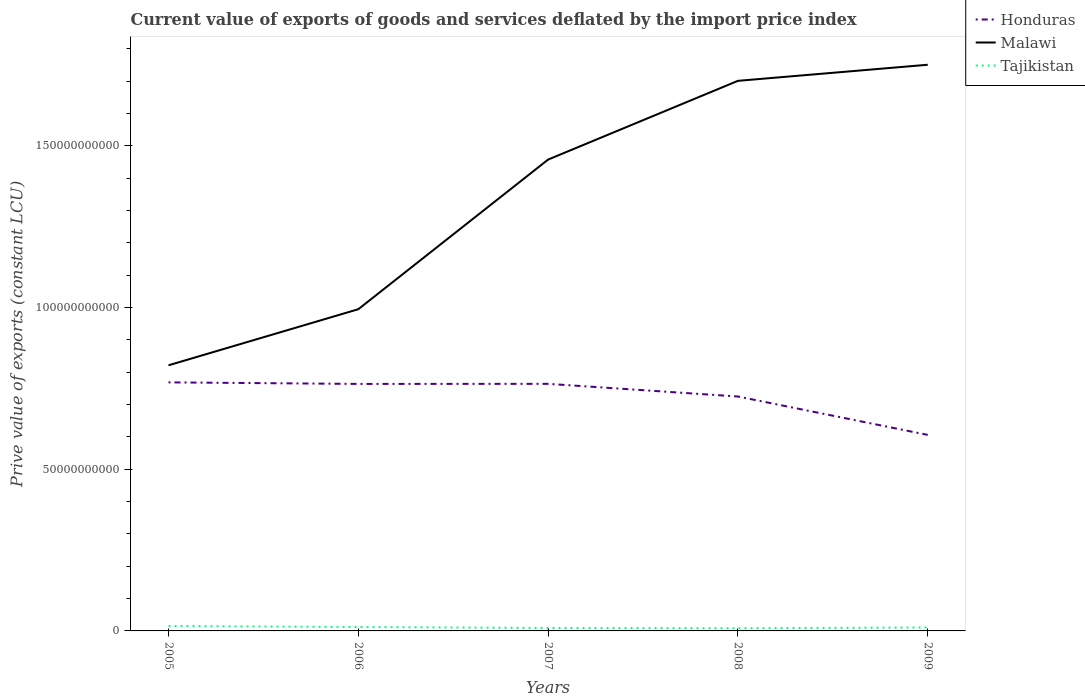Is the number of lines equal to the number of legend labels?
Make the answer very short. Yes. Across all years, what is the maximum prive value of exports in Honduras?
Your response must be concise. 6.06e+1. In which year was the prive value of exports in Tajikistan maximum?
Your response must be concise. 2008. What is the total prive value of exports in Tajikistan in the graph?
Your answer should be compact. 7.74e+07. What is the difference between the highest and the second highest prive value of exports in Honduras?
Provide a succinct answer. 1.62e+1. How many lines are there?
Offer a very short reply. 3. Where does the legend appear in the graph?
Make the answer very short. Top right. How many legend labels are there?
Your answer should be compact. 3. What is the title of the graph?
Your response must be concise. Current value of exports of goods and services deflated by the import price index. Does "Puerto Rico" appear as one of the legend labels in the graph?
Offer a very short reply. No. What is the label or title of the X-axis?
Ensure brevity in your answer.  Years. What is the label or title of the Y-axis?
Ensure brevity in your answer.  Prive value of exports (constant LCU). What is the Prive value of exports (constant LCU) in Honduras in 2005?
Provide a succinct answer. 7.68e+1. What is the Prive value of exports (constant LCU) of Malawi in 2005?
Offer a terse response. 8.21e+1. What is the Prive value of exports (constant LCU) of Tajikistan in 2005?
Your answer should be compact. 1.53e+09. What is the Prive value of exports (constant LCU) of Honduras in 2006?
Your answer should be compact. 7.64e+1. What is the Prive value of exports (constant LCU) of Malawi in 2006?
Your answer should be very brief. 9.95e+1. What is the Prive value of exports (constant LCU) of Tajikistan in 2006?
Make the answer very short. 1.21e+09. What is the Prive value of exports (constant LCU) of Honduras in 2007?
Provide a short and direct response. 7.64e+1. What is the Prive value of exports (constant LCU) of Malawi in 2007?
Offer a terse response. 1.46e+11. What is the Prive value of exports (constant LCU) of Tajikistan in 2007?
Your answer should be very brief. 9.08e+08. What is the Prive value of exports (constant LCU) of Honduras in 2008?
Offer a terse response. 7.25e+1. What is the Prive value of exports (constant LCU) of Malawi in 2008?
Give a very brief answer. 1.70e+11. What is the Prive value of exports (constant LCU) in Tajikistan in 2008?
Your response must be concise. 8.31e+08. What is the Prive value of exports (constant LCU) in Honduras in 2009?
Give a very brief answer. 6.06e+1. What is the Prive value of exports (constant LCU) of Malawi in 2009?
Provide a short and direct response. 1.75e+11. What is the Prive value of exports (constant LCU) in Tajikistan in 2009?
Your answer should be compact. 1.07e+09. Across all years, what is the maximum Prive value of exports (constant LCU) of Honduras?
Offer a very short reply. 7.68e+1. Across all years, what is the maximum Prive value of exports (constant LCU) in Malawi?
Offer a very short reply. 1.75e+11. Across all years, what is the maximum Prive value of exports (constant LCU) in Tajikistan?
Provide a succinct answer. 1.53e+09. Across all years, what is the minimum Prive value of exports (constant LCU) in Honduras?
Ensure brevity in your answer.  6.06e+1. Across all years, what is the minimum Prive value of exports (constant LCU) in Malawi?
Offer a very short reply. 8.21e+1. Across all years, what is the minimum Prive value of exports (constant LCU) of Tajikistan?
Provide a short and direct response. 8.31e+08. What is the total Prive value of exports (constant LCU) in Honduras in the graph?
Give a very brief answer. 3.63e+11. What is the total Prive value of exports (constant LCU) in Malawi in the graph?
Provide a succinct answer. 6.72e+11. What is the total Prive value of exports (constant LCU) of Tajikistan in the graph?
Your answer should be very brief. 5.54e+09. What is the difference between the Prive value of exports (constant LCU) in Honduras in 2005 and that in 2006?
Ensure brevity in your answer.  4.82e+08. What is the difference between the Prive value of exports (constant LCU) of Malawi in 2005 and that in 2006?
Your answer should be very brief. -1.73e+1. What is the difference between the Prive value of exports (constant LCU) in Tajikistan in 2005 and that in 2006?
Your response must be concise. 3.24e+08. What is the difference between the Prive value of exports (constant LCU) of Honduras in 2005 and that in 2007?
Offer a terse response. 4.58e+08. What is the difference between the Prive value of exports (constant LCU) in Malawi in 2005 and that in 2007?
Ensure brevity in your answer.  -6.36e+1. What is the difference between the Prive value of exports (constant LCU) of Tajikistan in 2005 and that in 2007?
Offer a very short reply. 6.22e+08. What is the difference between the Prive value of exports (constant LCU) in Honduras in 2005 and that in 2008?
Offer a very short reply. 4.37e+09. What is the difference between the Prive value of exports (constant LCU) in Malawi in 2005 and that in 2008?
Your answer should be very brief. -8.80e+1. What is the difference between the Prive value of exports (constant LCU) of Tajikistan in 2005 and that in 2008?
Keep it short and to the point. 6.99e+08. What is the difference between the Prive value of exports (constant LCU) in Honduras in 2005 and that in 2009?
Your answer should be very brief. 1.62e+1. What is the difference between the Prive value of exports (constant LCU) in Malawi in 2005 and that in 2009?
Keep it short and to the point. -9.29e+1. What is the difference between the Prive value of exports (constant LCU) in Tajikistan in 2005 and that in 2009?
Make the answer very short. 4.65e+08. What is the difference between the Prive value of exports (constant LCU) in Honduras in 2006 and that in 2007?
Your answer should be compact. -2.36e+07. What is the difference between the Prive value of exports (constant LCU) in Malawi in 2006 and that in 2007?
Make the answer very short. -4.63e+1. What is the difference between the Prive value of exports (constant LCU) in Tajikistan in 2006 and that in 2007?
Offer a very short reply. 2.98e+08. What is the difference between the Prive value of exports (constant LCU) of Honduras in 2006 and that in 2008?
Offer a terse response. 3.89e+09. What is the difference between the Prive value of exports (constant LCU) in Malawi in 2006 and that in 2008?
Your answer should be very brief. -7.06e+1. What is the difference between the Prive value of exports (constant LCU) of Tajikistan in 2006 and that in 2008?
Offer a very short reply. 3.76e+08. What is the difference between the Prive value of exports (constant LCU) in Honduras in 2006 and that in 2009?
Ensure brevity in your answer.  1.58e+1. What is the difference between the Prive value of exports (constant LCU) of Malawi in 2006 and that in 2009?
Give a very brief answer. -7.56e+1. What is the difference between the Prive value of exports (constant LCU) of Tajikistan in 2006 and that in 2009?
Give a very brief answer. 1.41e+08. What is the difference between the Prive value of exports (constant LCU) of Honduras in 2007 and that in 2008?
Your response must be concise. 3.92e+09. What is the difference between the Prive value of exports (constant LCU) in Malawi in 2007 and that in 2008?
Your answer should be compact. -2.43e+1. What is the difference between the Prive value of exports (constant LCU) in Tajikistan in 2007 and that in 2008?
Make the answer very short. 7.74e+07. What is the difference between the Prive value of exports (constant LCU) of Honduras in 2007 and that in 2009?
Keep it short and to the point. 1.58e+1. What is the difference between the Prive value of exports (constant LCU) in Malawi in 2007 and that in 2009?
Keep it short and to the point. -2.93e+1. What is the difference between the Prive value of exports (constant LCU) in Tajikistan in 2007 and that in 2009?
Provide a succinct answer. -1.57e+08. What is the difference between the Prive value of exports (constant LCU) in Honduras in 2008 and that in 2009?
Make the answer very short. 1.19e+1. What is the difference between the Prive value of exports (constant LCU) in Malawi in 2008 and that in 2009?
Give a very brief answer. -4.97e+09. What is the difference between the Prive value of exports (constant LCU) in Tajikistan in 2008 and that in 2009?
Offer a very short reply. -2.35e+08. What is the difference between the Prive value of exports (constant LCU) in Honduras in 2005 and the Prive value of exports (constant LCU) in Malawi in 2006?
Your answer should be very brief. -2.26e+1. What is the difference between the Prive value of exports (constant LCU) of Honduras in 2005 and the Prive value of exports (constant LCU) of Tajikistan in 2006?
Offer a terse response. 7.56e+1. What is the difference between the Prive value of exports (constant LCU) in Malawi in 2005 and the Prive value of exports (constant LCU) in Tajikistan in 2006?
Ensure brevity in your answer.  8.09e+1. What is the difference between the Prive value of exports (constant LCU) of Honduras in 2005 and the Prive value of exports (constant LCU) of Malawi in 2007?
Offer a terse response. -6.89e+1. What is the difference between the Prive value of exports (constant LCU) in Honduras in 2005 and the Prive value of exports (constant LCU) in Tajikistan in 2007?
Make the answer very short. 7.59e+1. What is the difference between the Prive value of exports (constant LCU) of Malawi in 2005 and the Prive value of exports (constant LCU) of Tajikistan in 2007?
Offer a terse response. 8.12e+1. What is the difference between the Prive value of exports (constant LCU) in Honduras in 2005 and the Prive value of exports (constant LCU) in Malawi in 2008?
Your answer should be compact. -9.32e+1. What is the difference between the Prive value of exports (constant LCU) in Honduras in 2005 and the Prive value of exports (constant LCU) in Tajikistan in 2008?
Provide a succinct answer. 7.60e+1. What is the difference between the Prive value of exports (constant LCU) in Malawi in 2005 and the Prive value of exports (constant LCU) in Tajikistan in 2008?
Provide a succinct answer. 8.13e+1. What is the difference between the Prive value of exports (constant LCU) in Honduras in 2005 and the Prive value of exports (constant LCU) in Malawi in 2009?
Keep it short and to the point. -9.82e+1. What is the difference between the Prive value of exports (constant LCU) in Honduras in 2005 and the Prive value of exports (constant LCU) in Tajikistan in 2009?
Offer a very short reply. 7.58e+1. What is the difference between the Prive value of exports (constant LCU) in Malawi in 2005 and the Prive value of exports (constant LCU) in Tajikistan in 2009?
Your response must be concise. 8.11e+1. What is the difference between the Prive value of exports (constant LCU) of Honduras in 2006 and the Prive value of exports (constant LCU) of Malawi in 2007?
Give a very brief answer. -6.94e+1. What is the difference between the Prive value of exports (constant LCU) in Honduras in 2006 and the Prive value of exports (constant LCU) in Tajikistan in 2007?
Ensure brevity in your answer.  7.55e+1. What is the difference between the Prive value of exports (constant LCU) of Malawi in 2006 and the Prive value of exports (constant LCU) of Tajikistan in 2007?
Provide a succinct answer. 9.86e+1. What is the difference between the Prive value of exports (constant LCU) of Honduras in 2006 and the Prive value of exports (constant LCU) of Malawi in 2008?
Provide a succinct answer. -9.37e+1. What is the difference between the Prive value of exports (constant LCU) in Honduras in 2006 and the Prive value of exports (constant LCU) in Tajikistan in 2008?
Your answer should be very brief. 7.55e+1. What is the difference between the Prive value of exports (constant LCU) in Malawi in 2006 and the Prive value of exports (constant LCU) in Tajikistan in 2008?
Make the answer very short. 9.86e+1. What is the difference between the Prive value of exports (constant LCU) in Honduras in 2006 and the Prive value of exports (constant LCU) in Malawi in 2009?
Make the answer very short. -9.87e+1. What is the difference between the Prive value of exports (constant LCU) in Honduras in 2006 and the Prive value of exports (constant LCU) in Tajikistan in 2009?
Offer a very short reply. 7.53e+1. What is the difference between the Prive value of exports (constant LCU) in Malawi in 2006 and the Prive value of exports (constant LCU) in Tajikistan in 2009?
Offer a terse response. 9.84e+1. What is the difference between the Prive value of exports (constant LCU) of Honduras in 2007 and the Prive value of exports (constant LCU) of Malawi in 2008?
Ensure brevity in your answer.  -9.37e+1. What is the difference between the Prive value of exports (constant LCU) in Honduras in 2007 and the Prive value of exports (constant LCU) in Tajikistan in 2008?
Provide a succinct answer. 7.56e+1. What is the difference between the Prive value of exports (constant LCU) in Malawi in 2007 and the Prive value of exports (constant LCU) in Tajikistan in 2008?
Give a very brief answer. 1.45e+11. What is the difference between the Prive value of exports (constant LCU) of Honduras in 2007 and the Prive value of exports (constant LCU) of Malawi in 2009?
Your response must be concise. -9.87e+1. What is the difference between the Prive value of exports (constant LCU) of Honduras in 2007 and the Prive value of exports (constant LCU) of Tajikistan in 2009?
Your response must be concise. 7.53e+1. What is the difference between the Prive value of exports (constant LCU) of Malawi in 2007 and the Prive value of exports (constant LCU) of Tajikistan in 2009?
Keep it short and to the point. 1.45e+11. What is the difference between the Prive value of exports (constant LCU) of Honduras in 2008 and the Prive value of exports (constant LCU) of Malawi in 2009?
Give a very brief answer. -1.03e+11. What is the difference between the Prive value of exports (constant LCU) in Honduras in 2008 and the Prive value of exports (constant LCU) in Tajikistan in 2009?
Your response must be concise. 7.14e+1. What is the difference between the Prive value of exports (constant LCU) in Malawi in 2008 and the Prive value of exports (constant LCU) in Tajikistan in 2009?
Make the answer very short. 1.69e+11. What is the average Prive value of exports (constant LCU) in Honduras per year?
Give a very brief answer. 7.25e+1. What is the average Prive value of exports (constant LCU) in Malawi per year?
Provide a short and direct response. 1.34e+11. What is the average Prive value of exports (constant LCU) of Tajikistan per year?
Offer a terse response. 1.11e+09. In the year 2005, what is the difference between the Prive value of exports (constant LCU) of Honduras and Prive value of exports (constant LCU) of Malawi?
Provide a short and direct response. -5.27e+09. In the year 2005, what is the difference between the Prive value of exports (constant LCU) of Honduras and Prive value of exports (constant LCU) of Tajikistan?
Provide a succinct answer. 7.53e+1. In the year 2005, what is the difference between the Prive value of exports (constant LCU) of Malawi and Prive value of exports (constant LCU) of Tajikistan?
Your answer should be compact. 8.06e+1. In the year 2006, what is the difference between the Prive value of exports (constant LCU) of Honduras and Prive value of exports (constant LCU) of Malawi?
Offer a terse response. -2.31e+1. In the year 2006, what is the difference between the Prive value of exports (constant LCU) of Honduras and Prive value of exports (constant LCU) of Tajikistan?
Provide a short and direct response. 7.52e+1. In the year 2006, what is the difference between the Prive value of exports (constant LCU) of Malawi and Prive value of exports (constant LCU) of Tajikistan?
Offer a very short reply. 9.83e+1. In the year 2007, what is the difference between the Prive value of exports (constant LCU) of Honduras and Prive value of exports (constant LCU) of Malawi?
Your answer should be compact. -6.93e+1. In the year 2007, what is the difference between the Prive value of exports (constant LCU) in Honduras and Prive value of exports (constant LCU) in Tajikistan?
Provide a short and direct response. 7.55e+1. In the year 2007, what is the difference between the Prive value of exports (constant LCU) in Malawi and Prive value of exports (constant LCU) in Tajikistan?
Ensure brevity in your answer.  1.45e+11. In the year 2008, what is the difference between the Prive value of exports (constant LCU) of Honduras and Prive value of exports (constant LCU) of Malawi?
Your answer should be compact. -9.76e+1. In the year 2008, what is the difference between the Prive value of exports (constant LCU) of Honduras and Prive value of exports (constant LCU) of Tajikistan?
Your answer should be very brief. 7.16e+1. In the year 2008, what is the difference between the Prive value of exports (constant LCU) in Malawi and Prive value of exports (constant LCU) in Tajikistan?
Provide a succinct answer. 1.69e+11. In the year 2009, what is the difference between the Prive value of exports (constant LCU) of Honduras and Prive value of exports (constant LCU) of Malawi?
Provide a succinct answer. -1.14e+11. In the year 2009, what is the difference between the Prive value of exports (constant LCU) of Honduras and Prive value of exports (constant LCU) of Tajikistan?
Provide a short and direct response. 5.95e+1. In the year 2009, what is the difference between the Prive value of exports (constant LCU) of Malawi and Prive value of exports (constant LCU) of Tajikistan?
Keep it short and to the point. 1.74e+11. What is the ratio of the Prive value of exports (constant LCU) in Honduras in 2005 to that in 2006?
Ensure brevity in your answer.  1.01. What is the ratio of the Prive value of exports (constant LCU) in Malawi in 2005 to that in 2006?
Ensure brevity in your answer.  0.83. What is the ratio of the Prive value of exports (constant LCU) in Tajikistan in 2005 to that in 2006?
Your answer should be very brief. 1.27. What is the ratio of the Prive value of exports (constant LCU) of Malawi in 2005 to that in 2007?
Keep it short and to the point. 0.56. What is the ratio of the Prive value of exports (constant LCU) of Tajikistan in 2005 to that in 2007?
Offer a terse response. 1.68. What is the ratio of the Prive value of exports (constant LCU) in Honduras in 2005 to that in 2008?
Make the answer very short. 1.06. What is the ratio of the Prive value of exports (constant LCU) in Malawi in 2005 to that in 2008?
Offer a very short reply. 0.48. What is the ratio of the Prive value of exports (constant LCU) of Tajikistan in 2005 to that in 2008?
Your response must be concise. 1.84. What is the ratio of the Prive value of exports (constant LCU) in Honduras in 2005 to that in 2009?
Give a very brief answer. 1.27. What is the ratio of the Prive value of exports (constant LCU) of Malawi in 2005 to that in 2009?
Keep it short and to the point. 0.47. What is the ratio of the Prive value of exports (constant LCU) in Tajikistan in 2005 to that in 2009?
Give a very brief answer. 1.44. What is the ratio of the Prive value of exports (constant LCU) of Honduras in 2006 to that in 2007?
Ensure brevity in your answer.  1. What is the ratio of the Prive value of exports (constant LCU) of Malawi in 2006 to that in 2007?
Make the answer very short. 0.68. What is the ratio of the Prive value of exports (constant LCU) in Tajikistan in 2006 to that in 2007?
Make the answer very short. 1.33. What is the ratio of the Prive value of exports (constant LCU) in Honduras in 2006 to that in 2008?
Provide a short and direct response. 1.05. What is the ratio of the Prive value of exports (constant LCU) in Malawi in 2006 to that in 2008?
Keep it short and to the point. 0.58. What is the ratio of the Prive value of exports (constant LCU) in Tajikistan in 2006 to that in 2008?
Your answer should be very brief. 1.45. What is the ratio of the Prive value of exports (constant LCU) in Honduras in 2006 to that in 2009?
Provide a succinct answer. 1.26. What is the ratio of the Prive value of exports (constant LCU) of Malawi in 2006 to that in 2009?
Provide a short and direct response. 0.57. What is the ratio of the Prive value of exports (constant LCU) in Tajikistan in 2006 to that in 2009?
Offer a terse response. 1.13. What is the ratio of the Prive value of exports (constant LCU) of Honduras in 2007 to that in 2008?
Ensure brevity in your answer.  1.05. What is the ratio of the Prive value of exports (constant LCU) of Malawi in 2007 to that in 2008?
Your answer should be compact. 0.86. What is the ratio of the Prive value of exports (constant LCU) in Tajikistan in 2007 to that in 2008?
Your response must be concise. 1.09. What is the ratio of the Prive value of exports (constant LCU) of Honduras in 2007 to that in 2009?
Keep it short and to the point. 1.26. What is the ratio of the Prive value of exports (constant LCU) of Malawi in 2007 to that in 2009?
Your response must be concise. 0.83. What is the ratio of the Prive value of exports (constant LCU) in Tajikistan in 2007 to that in 2009?
Keep it short and to the point. 0.85. What is the ratio of the Prive value of exports (constant LCU) of Honduras in 2008 to that in 2009?
Give a very brief answer. 1.2. What is the ratio of the Prive value of exports (constant LCU) of Malawi in 2008 to that in 2009?
Your answer should be very brief. 0.97. What is the ratio of the Prive value of exports (constant LCU) of Tajikistan in 2008 to that in 2009?
Your response must be concise. 0.78. What is the difference between the highest and the second highest Prive value of exports (constant LCU) of Honduras?
Your response must be concise. 4.58e+08. What is the difference between the highest and the second highest Prive value of exports (constant LCU) in Malawi?
Provide a short and direct response. 4.97e+09. What is the difference between the highest and the second highest Prive value of exports (constant LCU) of Tajikistan?
Keep it short and to the point. 3.24e+08. What is the difference between the highest and the lowest Prive value of exports (constant LCU) in Honduras?
Make the answer very short. 1.62e+1. What is the difference between the highest and the lowest Prive value of exports (constant LCU) of Malawi?
Offer a terse response. 9.29e+1. What is the difference between the highest and the lowest Prive value of exports (constant LCU) in Tajikistan?
Give a very brief answer. 6.99e+08. 